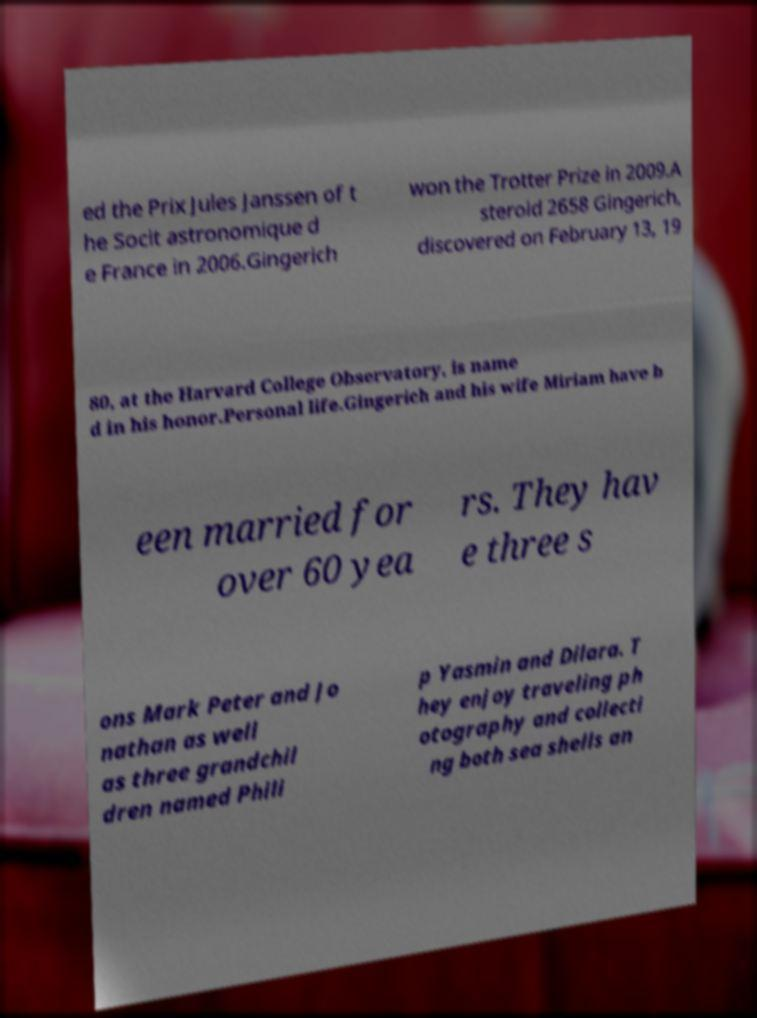Can you accurately transcribe the text from the provided image for me? ed the Prix Jules Janssen of t he Socit astronomique d e France in 2006.Gingerich won the Trotter Prize in 2009.A steroid 2658 Gingerich, discovered on February 13, 19 80, at the Harvard College Observatory, is name d in his honor.Personal life.Gingerich and his wife Miriam have b een married for over 60 yea rs. They hav e three s ons Mark Peter and Jo nathan as well as three grandchil dren named Phili p Yasmin and Dilara. T hey enjoy traveling ph otography and collecti ng both sea shells an 